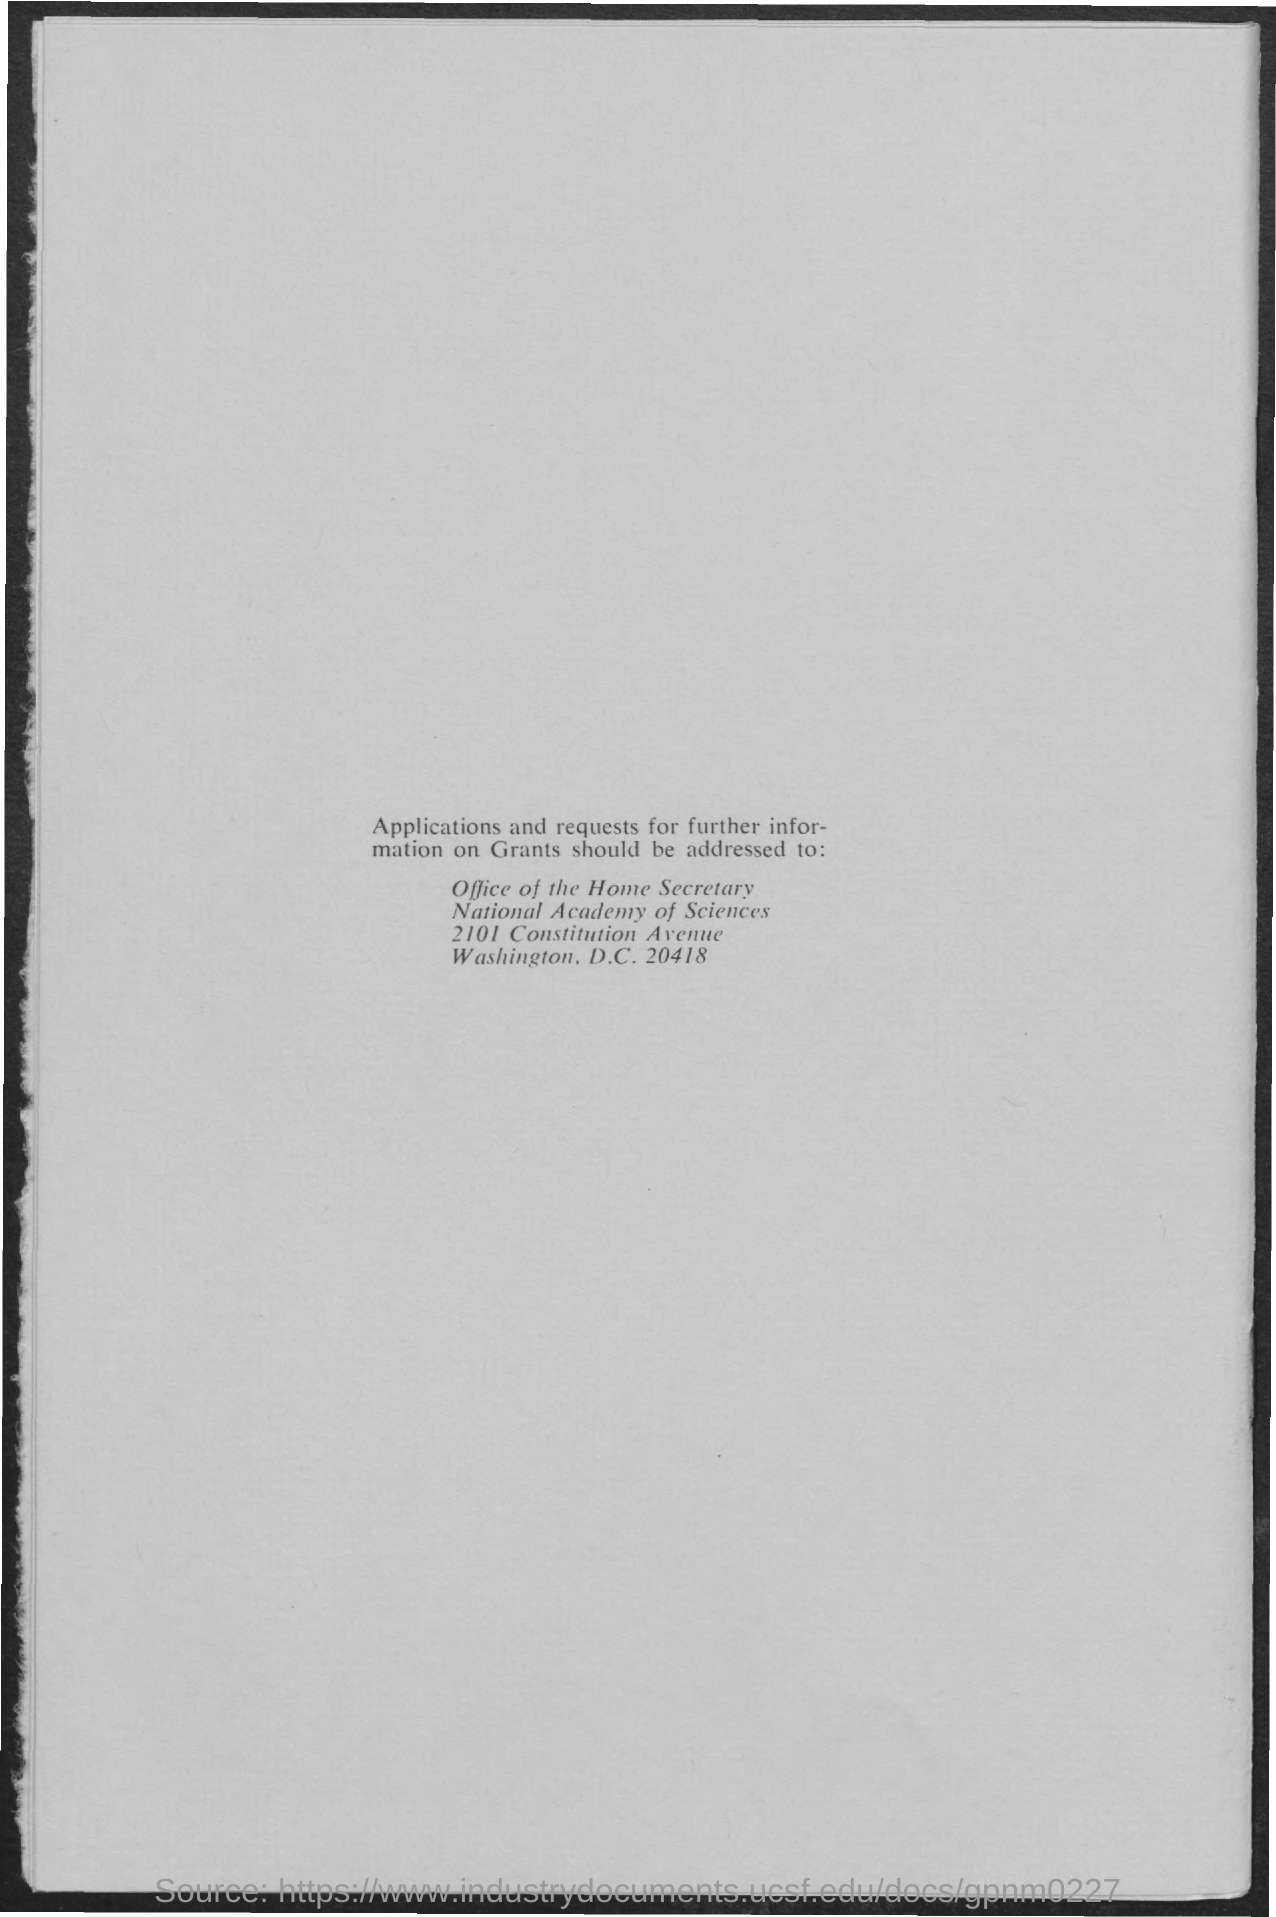Indicate a few pertinent items in this graphic. The National Academy of Sciences is the name of the academy. The zip code of the National Academy of Sciences is 20418. 